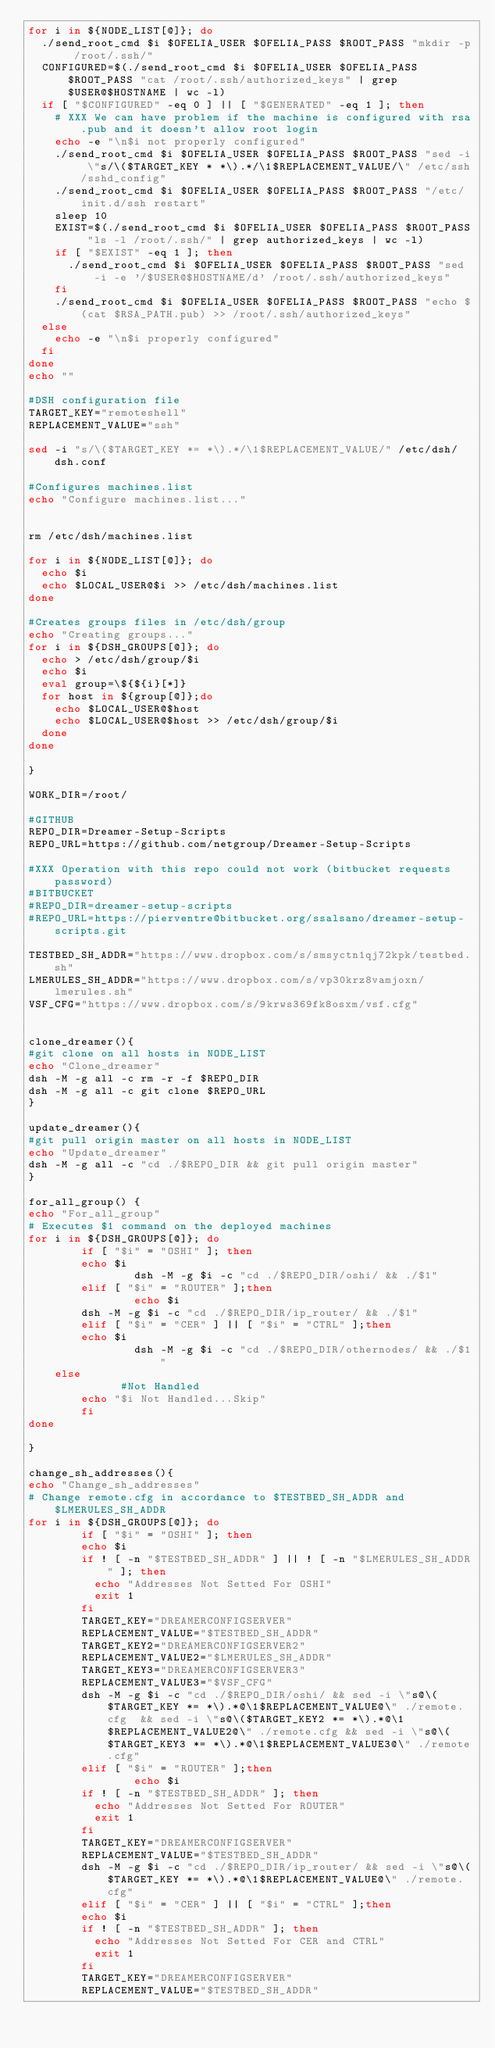<code> <loc_0><loc_0><loc_500><loc_500><_Bash_>for i in ${NODE_LIST[@]}; do
	./send_root_cmd $i $OFELIA_USER $OFELIA_PASS $ROOT_PASS "mkdir -p /root/.ssh/"
	CONFIGURED=$(./send_root_cmd $i $OFELIA_USER $OFELIA_PASS $ROOT_PASS "cat /root/.ssh/authorized_keys" | grep $USER@$HOSTNAME | wc -l)
	if [ "$CONFIGURED" -eq 0 ] || [ "$GENERATED" -eq 1 ]; then
		# XXX We can have problem if the machine is configured with rsa.pub and it doesn't allow root login
		echo -e "\n$i not properly configured"
		./send_root_cmd $i $OFELIA_USER $OFELIA_PASS $ROOT_PASS "sed -i \"s/\($TARGET_KEY * *\).*/\1$REPLACEMENT_VALUE/\" /etc/ssh/sshd_config"
		./send_root_cmd $i $OFELIA_USER $OFELIA_PASS $ROOT_PASS "/etc/init.d/ssh restart"
		sleep 10
		EXIST=$(./send_root_cmd $i $OFELIA_USER $OFELIA_PASS $ROOT_PASS "ls -l /root/.ssh/" | grep authorized_keys | wc -l)
		if [ "$EXIST" -eq 1 ]; then
			./send_root_cmd $i $OFELIA_USER $OFELIA_PASS $ROOT_PASS "sed -i -e '/$USER@$HOSTNAME/d' /root/.ssh/authorized_keys"
		fi	 	
		./send_root_cmd $i $OFELIA_USER $OFELIA_PASS $ROOT_PASS "echo $(cat $RSA_PATH.pub) >> /root/.ssh/authorized_keys"
	else
		echo -e "\n$i properly configured"	
	fi
done
echo ""

#DSH configuration file
TARGET_KEY="remoteshell"
REPLACEMENT_VALUE="ssh"

sed -i "s/\($TARGET_KEY *= *\).*/\1$REPLACEMENT_VALUE/" /etc/dsh/dsh.conf

#Configures machines.list
echo "Configure machines.list..."


rm /etc/dsh/machines.list

for i in ${NODE_LIST[@]}; do
	echo $i
	echo $LOCAL_USER@$i >> /etc/dsh/machines.list
done

#Creates groups files in /etc/dsh/group
echo "Creating groups..."
for i in ${DSH_GROUPS[@]}; do
	echo > /etc/dsh/group/$i
	echo $i
	eval group=\${${i}[*]}
	for host in ${group[@]};do
		echo $LOCAL_USER@$host
		echo $LOCAL_USER@$host >> /etc/dsh/group/$i
	done	
done

}

WORK_DIR=/root/

#GITHUB
REPO_DIR=Dreamer-Setup-Scripts
REPO_URL=https://github.com/netgroup/Dreamer-Setup-Scripts

#XXX Operation with this repo could not work (bitbucket requests password)
#BITBUCKET
#REPO_DIR=dreamer-setup-scripts
#REPO_URL=https://pierventre@bitbucket.org/ssalsano/dreamer-setup-scripts.git

TESTBED_SH_ADDR="https://www.dropbox.com/s/smsyctn1qj72kpk/testbed.sh"
LMERULES_SH_ADDR="https://www.dropbox.com/s/vp30krz8vamjoxn/lmerules.sh"
VSF_CFG="https://www.dropbox.com/s/9krws369fk8osxm/vsf.cfg"


clone_dreamer(){
#git clone on all hosts in NODE_LIST
echo "Clone_dreamer"
dsh -M -g all -c rm -r -f $REPO_DIR
dsh -M -g all -c git clone $REPO_URL
}

update_dreamer(){
#git pull origin master on all hosts in NODE_LIST
echo "Update_dreamer"
dsh -M -g all -c "cd ./$REPO_DIR && git pull origin master"
}

for_all_group() {
echo "For_all_group"
# Executes $1 command on the deployed machines
for i in ${DSH_GROUPS[@]}; do
        if [ "$i" = "OSHI" ]; then
				echo $i
                dsh -M -g $i -c "cd ./$REPO_DIR/oshi/ && ./$1" 
        elif [ "$i" = "ROUTER" ];then
                echo $i
				dsh -M -g $i -c "cd ./$REPO_DIR/ip_router/ && ./$1"  
        elif [ "$i" = "CER" ] || [ "$i" = "CTRL" ];then
				echo $i
                dsh -M -g $i -c "cd ./$REPO_DIR/othernodes/ && ./$1" 
		else    
            	#Not Handled
				echo "$i Not Handled...Skip"			 
        fi
done

}

change_sh_addresses(){
echo "Change_sh_addresses"
# Change remote.cfg in accordance to $TESTBED_SH_ADDR and $LMERULES_SH_ADDR
for i in ${DSH_GROUPS[@]}; do
        if [ "$i" = "OSHI" ]; then
				echo $i
				if ! [ -n "$TESTBED_SH_ADDR" ] || ! [ -n "$LMERULES_SH_ADDR" ]; then
					echo "Addresses Not Setted For OSHI"
					exit 1
				fi
				TARGET_KEY="DREAMERCONFIGSERVER"
				REPLACEMENT_VALUE="$TESTBED_SH_ADDR"
				TARGET_KEY2="DREAMERCONFIGSERVER2"
				REPLACEMENT_VALUE2="$LMERULES_SH_ADDR"
				TARGET_KEY3="DREAMERCONFIGSERVER3"
				REPLACEMENT_VALUE3="$VSF_CFG"
				dsh -M -g $i -c "cd ./$REPO_DIR/oshi/ && sed -i \"s@\($TARGET_KEY *= *\).*@\1$REPLACEMENT_VALUE@\" ./remote.cfg  && sed -i \"s@\($TARGET_KEY2 *= *\).*@\1$REPLACEMENT_VALUE2@\" ./remote.cfg && sed -i \"s@\($TARGET_KEY3 *= *\).*@\1$REPLACEMENT_VALUE3@\" ./remote.cfg"
        elif [ "$i" = "ROUTER" ];then
                echo $i
				if ! [ -n "$TESTBED_SH_ADDR" ]; then
					echo "Addresses Not Setted For ROUTER"
					exit 1
				fi
				TARGET_KEY="DREAMERCONFIGSERVER"
				REPLACEMENT_VALUE="$TESTBED_SH_ADDR"
				dsh -M -g $i -c "cd ./$REPO_DIR/ip_router/ && sed -i \"s@\($TARGET_KEY *= *\).*@\1$REPLACEMENT_VALUE@\" ./remote.cfg"
        elif [ "$i" = "CER" ] || [ "$i" = "CTRL" ];then
				echo $i
				if ! [ -n "$TESTBED_SH_ADDR" ]; then
					echo "Addresses Not Setted For CER and CTRL"
					exit 1
				fi
				TARGET_KEY="DREAMERCONFIGSERVER"
				REPLACEMENT_VALUE="$TESTBED_SH_ADDR"</code> 